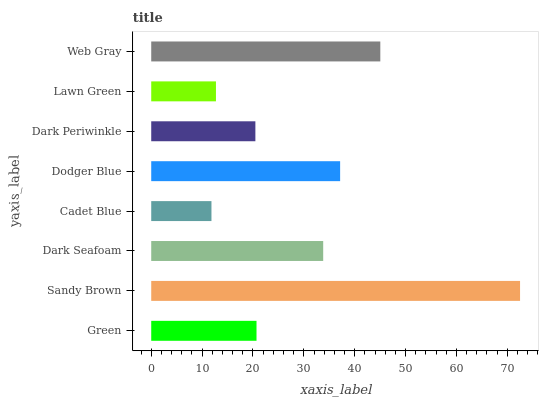Is Cadet Blue the minimum?
Answer yes or no. Yes. Is Sandy Brown the maximum?
Answer yes or no. Yes. Is Dark Seafoam the minimum?
Answer yes or no. No. Is Dark Seafoam the maximum?
Answer yes or no. No. Is Sandy Brown greater than Dark Seafoam?
Answer yes or no. Yes. Is Dark Seafoam less than Sandy Brown?
Answer yes or no. Yes. Is Dark Seafoam greater than Sandy Brown?
Answer yes or no. No. Is Sandy Brown less than Dark Seafoam?
Answer yes or no. No. Is Dark Seafoam the high median?
Answer yes or no. Yes. Is Green the low median?
Answer yes or no. Yes. Is Sandy Brown the high median?
Answer yes or no. No. Is Lawn Green the low median?
Answer yes or no. No. 